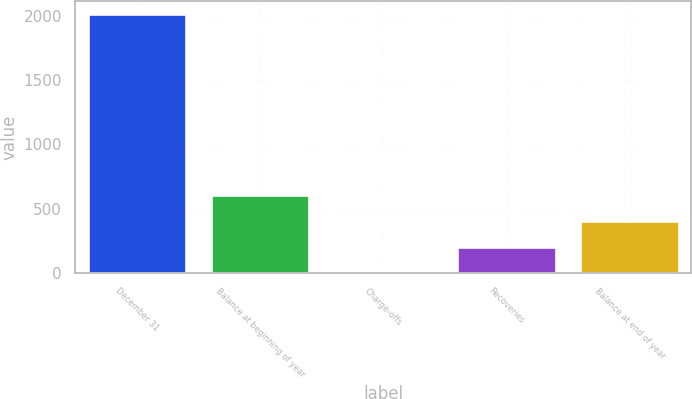Convert chart to OTSL. <chart><loc_0><loc_0><loc_500><loc_500><bar_chart><fcel>December 31<fcel>Balance at beginning of year<fcel>Charge-offs<fcel>Recoveries<fcel>Balance at end of year<nl><fcel>2015<fcel>606.6<fcel>3<fcel>204.2<fcel>405.4<nl></chart> 